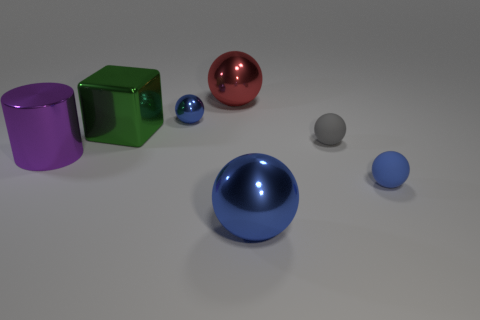What is the material of the cube that is the same size as the purple metal object? metal 